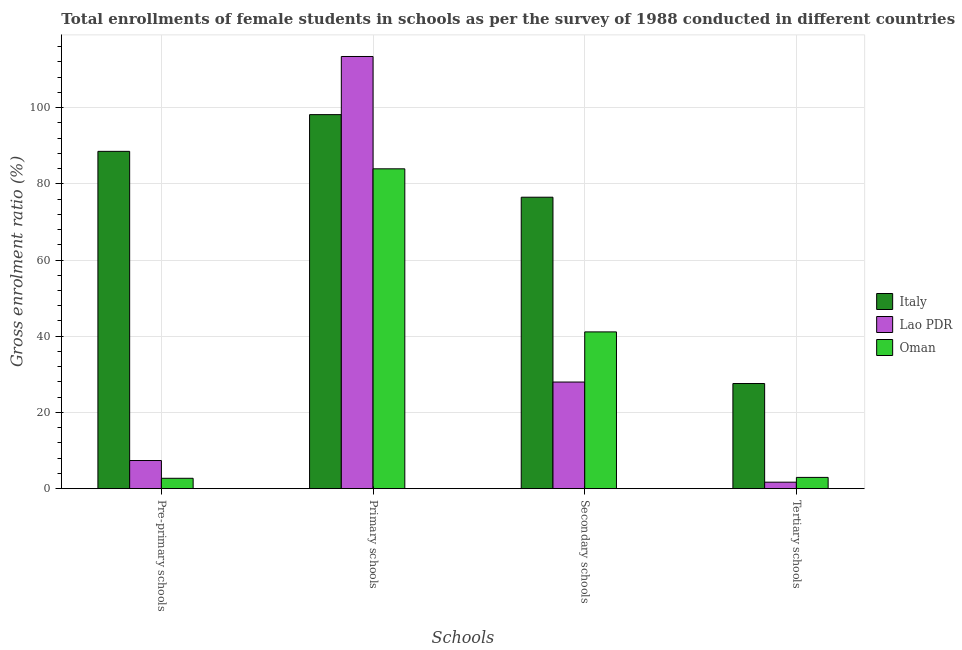How many different coloured bars are there?
Make the answer very short. 3. How many groups of bars are there?
Your response must be concise. 4. Are the number of bars on each tick of the X-axis equal?
Make the answer very short. Yes. How many bars are there on the 3rd tick from the right?
Your answer should be compact. 3. What is the label of the 4th group of bars from the left?
Your response must be concise. Tertiary schools. What is the gross enrolment ratio(female) in secondary schools in Italy?
Provide a short and direct response. 76.48. Across all countries, what is the maximum gross enrolment ratio(female) in primary schools?
Ensure brevity in your answer.  113.4. Across all countries, what is the minimum gross enrolment ratio(female) in pre-primary schools?
Provide a succinct answer. 2.73. In which country was the gross enrolment ratio(female) in pre-primary schools minimum?
Offer a very short reply. Oman. What is the total gross enrolment ratio(female) in primary schools in the graph?
Ensure brevity in your answer.  295.46. What is the difference between the gross enrolment ratio(female) in tertiary schools in Oman and that in Lao PDR?
Keep it short and to the point. 1.25. What is the difference between the gross enrolment ratio(female) in secondary schools in Lao PDR and the gross enrolment ratio(female) in tertiary schools in Italy?
Offer a terse response. 0.39. What is the average gross enrolment ratio(female) in secondary schools per country?
Ensure brevity in your answer.  48.53. What is the difference between the gross enrolment ratio(female) in tertiary schools and gross enrolment ratio(female) in primary schools in Lao PDR?
Your answer should be very brief. -111.69. What is the ratio of the gross enrolment ratio(female) in secondary schools in Lao PDR to that in Italy?
Keep it short and to the point. 0.37. Is the difference between the gross enrolment ratio(female) in pre-primary schools in Oman and Italy greater than the difference between the gross enrolment ratio(female) in primary schools in Oman and Italy?
Your response must be concise. No. What is the difference between the highest and the second highest gross enrolment ratio(female) in tertiary schools?
Offer a very short reply. 24.63. What is the difference between the highest and the lowest gross enrolment ratio(female) in tertiary schools?
Offer a very short reply. 25.88. Is it the case that in every country, the sum of the gross enrolment ratio(female) in primary schools and gross enrolment ratio(female) in pre-primary schools is greater than the sum of gross enrolment ratio(female) in tertiary schools and gross enrolment ratio(female) in secondary schools?
Keep it short and to the point. No. What does the 2nd bar from the left in Tertiary schools represents?
Offer a very short reply. Lao PDR. What does the 2nd bar from the right in Secondary schools represents?
Your answer should be compact. Lao PDR. Are the values on the major ticks of Y-axis written in scientific E-notation?
Provide a succinct answer. No. Does the graph contain grids?
Make the answer very short. Yes. What is the title of the graph?
Keep it short and to the point. Total enrollments of female students in schools as per the survey of 1988 conducted in different countries. What is the label or title of the X-axis?
Keep it short and to the point. Schools. What is the Gross enrolment ratio (%) of Italy in Pre-primary schools?
Ensure brevity in your answer.  88.51. What is the Gross enrolment ratio (%) in Lao PDR in Pre-primary schools?
Ensure brevity in your answer.  7.39. What is the Gross enrolment ratio (%) of Oman in Pre-primary schools?
Your answer should be very brief. 2.73. What is the Gross enrolment ratio (%) of Italy in Primary schools?
Your answer should be very brief. 98.14. What is the Gross enrolment ratio (%) in Lao PDR in Primary schools?
Keep it short and to the point. 113.4. What is the Gross enrolment ratio (%) in Oman in Primary schools?
Keep it short and to the point. 83.92. What is the Gross enrolment ratio (%) of Italy in Secondary schools?
Offer a very short reply. 76.48. What is the Gross enrolment ratio (%) in Lao PDR in Secondary schools?
Your answer should be compact. 27.98. What is the Gross enrolment ratio (%) of Oman in Secondary schools?
Offer a terse response. 41.14. What is the Gross enrolment ratio (%) of Italy in Tertiary schools?
Ensure brevity in your answer.  27.59. What is the Gross enrolment ratio (%) in Lao PDR in Tertiary schools?
Offer a terse response. 1.71. What is the Gross enrolment ratio (%) of Oman in Tertiary schools?
Make the answer very short. 2.96. Across all Schools, what is the maximum Gross enrolment ratio (%) in Italy?
Provide a short and direct response. 98.14. Across all Schools, what is the maximum Gross enrolment ratio (%) of Lao PDR?
Offer a terse response. 113.4. Across all Schools, what is the maximum Gross enrolment ratio (%) in Oman?
Make the answer very short. 83.92. Across all Schools, what is the minimum Gross enrolment ratio (%) of Italy?
Offer a terse response. 27.59. Across all Schools, what is the minimum Gross enrolment ratio (%) in Lao PDR?
Your answer should be very brief. 1.71. Across all Schools, what is the minimum Gross enrolment ratio (%) of Oman?
Keep it short and to the point. 2.73. What is the total Gross enrolment ratio (%) of Italy in the graph?
Keep it short and to the point. 290.71. What is the total Gross enrolment ratio (%) of Lao PDR in the graph?
Provide a succinct answer. 150.47. What is the total Gross enrolment ratio (%) in Oman in the graph?
Ensure brevity in your answer.  130.74. What is the difference between the Gross enrolment ratio (%) in Italy in Pre-primary schools and that in Primary schools?
Provide a succinct answer. -9.63. What is the difference between the Gross enrolment ratio (%) in Lao PDR in Pre-primary schools and that in Primary schools?
Your answer should be very brief. -106.01. What is the difference between the Gross enrolment ratio (%) in Oman in Pre-primary schools and that in Primary schools?
Your answer should be very brief. -81.2. What is the difference between the Gross enrolment ratio (%) of Italy in Pre-primary schools and that in Secondary schools?
Give a very brief answer. 12.03. What is the difference between the Gross enrolment ratio (%) of Lao PDR in Pre-primary schools and that in Secondary schools?
Provide a short and direct response. -20.59. What is the difference between the Gross enrolment ratio (%) of Oman in Pre-primary schools and that in Secondary schools?
Your response must be concise. -38.41. What is the difference between the Gross enrolment ratio (%) of Italy in Pre-primary schools and that in Tertiary schools?
Make the answer very short. 60.92. What is the difference between the Gross enrolment ratio (%) in Lao PDR in Pre-primary schools and that in Tertiary schools?
Your response must be concise. 5.68. What is the difference between the Gross enrolment ratio (%) of Oman in Pre-primary schools and that in Tertiary schools?
Give a very brief answer. -0.23. What is the difference between the Gross enrolment ratio (%) in Italy in Primary schools and that in Secondary schools?
Provide a succinct answer. 21.66. What is the difference between the Gross enrolment ratio (%) of Lao PDR in Primary schools and that in Secondary schools?
Your answer should be compact. 85.42. What is the difference between the Gross enrolment ratio (%) of Oman in Primary schools and that in Secondary schools?
Your answer should be very brief. 42.79. What is the difference between the Gross enrolment ratio (%) of Italy in Primary schools and that in Tertiary schools?
Your response must be concise. 70.55. What is the difference between the Gross enrolment ratio (%) of Lao PDR in Primary schools and that in Tertiary schools?
Provide a succinct answer. 111.69. What is the difference between the Gross enrolment ratio (%) in Oman in Primary schools and that in Tertiary schools?
Provide a short and direct response. 80.97. What is the difference between the Gross enrolment ratio (%) in Italy in Secondary schools and that in Tertiary schools?
Make the answer very short. 48.89. What is the difference between the Gross enrolment ratio (%) in Lao PDR in Secondary schools and that in Tertiary schools?
Your answer should be compact. 26.27. What is the difference between the Gross enrolment ratio (%) of Oman in Secondary schools and that in Tertiary schools?
Your answer should be compact. 38.18. What is the difference between the Gross enrolment ratio (%) of Italy in Pre-primary schools and the Gross enrolment ratio (%) of Lao PDR in Primary schools?
Your response must be concise. -24.89. What is the difference between the Gross enrolment ratio (%) of Italy in Pre-primary schools and the Gross enrolment ratio (%) of Oman in Primary schools?
Ensure brevity in your answer.  4.58. What is the difference between the Gross enrolment ratio (%) in Lao PDR in Pre-primary schools and the Gross enrolment ratio (%) in Oman in Primary schools?
Your answer should be compact. -76.54. What is the difference between the Gross enrolment ratio (%) in Italy in Pre-primary schools and the Gross enrolment ratio (%) in Lao PDR in Secondary schools?
Ensure brevity in your answer.  60.53. What is the difference between the Gross enrolment ratio (%) in Italy in Pre-primary schools and the Gross enrolment ratio (%) in Oman in Secondary schools?
Ensure brevity in your answer.  47.37. What is the difference between the Gross enrolment ratio (%) in Lao PDR in Pre-primary schools and the Gross enrolment ratio (%) in Oman in Secondary schools?
Offer a terse response. -33.75. What is the difference between the Gross enrolment ratio (%) of Italy in Pre-primary schools and the Gross enrolment ratio (%) of Lao PDR in Tertiary schools?
Make the answer very short. 86.8. What is the difference between the Gross enrolment ratio (%) of Italy in Pre-primary schools and the Gross enrolment ratio (%) of Oman in Tertiary schools?
Provide a short and direct response. 85.55. What is the difference between the Gross enrolment ratio (%) in Lao PDR in Pre-primary schools and the Gross enrolment ratio (%) in Oman in Tertiary schools?
Give a very brief answer. 4.43. What is the difference between the Gross enrolment ratio (%) in Italy in Primary schools and the Gross enrolment ratio (%) in Lao PDR in Secondary schools?
Offer a terse response. 70.16. What is the difference between the Gross enrolment ratio (%) of Italy in Primary schools and the Gross enrolment ratio (%) of Oman in Secondary schools?
Provide a short and direct response. 57.01. What is the difference between the Gross enrolment ratio (%) in Lao PDR in Primary schools and the Gross enrolment ratio (%) in Oman in Secondary schools?
Make the answer very short. 72.26. What is the difference between the Gross enrolment ratio (%) of Italy in Primary schools and the Gross enrolment ratio (%) of Lao PDR in Tertiary schools?
Offer a very short reply. 96.44. What is the difference between the Gross enrolment ratio (%) in Italy in Primary schools and the Gross enrolment ratio (%) in Oman in Tertiary schools?
Your answer should be compact. 95.18. What is the difference between the Gross enrolment ratio (%) of Lao PDR in Primary schools and the Gross enrolment ratio (%) of Oman in Tertiary schools?
Keep it short and to the point. 110.44. What is the difference between the Gross enrolment ratio (%) in Italy in Secondary schools and the Gross enrolment ratio (%) in Lao PDR in Tertiary schools?
Offer a terse response. 74.77. What is the difference between the Gross enrolment ratio (%) in Italy in Secondary schools and the Gross enrolment ratio (%) in Oman in Tertiary schools?
Ensure brevity in your answer.  73.52. What is the difference between the Gross enrolment ratio (%) in Lao PDR in Secondary schools and the Gross enrolment ratio (%) in Oman in Tertiary schools?
Provide a short and direct response. 25.02. What is the average Gross enrolment ratio (%) of Italy per Schools?
Offer a terse response. 72.68. What is the average Gross enrolment ratio (%) in Lao PDR per Schools?
Make the answer very short. 37.62. What is the average Gross enrolment ratio (%) of Oman per Schools?
Provide a succinct answer. 32.69. What is the difference between the Gross enrolment ratio (%) of Italy and Gross enrolment ratio (%) of Lao PDR in Pre-primary schools?
Ensure brevity in your answer.  81.12. What is the difference between the Gross enrolment ratio (%) in Italy and Gross enrolment ratio (%) in Oman in Pre-primary schools?
Provide a succinct answer. 85.78. What is the difference between the Gross enrolment ratio (%) in Lao PDR and Gross enrolment ratio (%) in Oman in Pre-primary schools?
Make the answer very short. 4.66. What is the difference between the Gross enrolment ratio (%) in Italy and Gross enrolment ratio (%) in Lao PDR in Primary schools?
Make the answer very short. -15.26. What is the difference between the Gross enrolment ratio (%) of Italy and Gross enrolment ratio (%) of Oman in Primary schools?
Your answer should be very brief. 14.22. What is the difference between the Gross enrolment ratio (%) in Lao PDR and Gross enrolment ratio (%) in Oman in Primary schools?
Your answer should be very brief. 29.48. What is the difference between the Gross enrolment ratio (%) of Italy and Gross enrolment ratio (%) of Lao PDR in Secondary schools?
Your response must be concise. 48.5. What is the difference between the Gross enrolment ratio (%) in Italy and Gross enrolment ratio (%) in Oman in Secondary schools?
Your answer should be very brief. 35.34. What is the difference between the Gross enrolment ratio (%) of Lao PDR and Gross enrolment ratio (%) of Oman in Secondary schools?
Your answer should be very brief. -13.16. What is the difference between the Gross enrolment ratio (%) of Italy and Gross enrolment ratio (%) of Lao PDR in Tertiary schools?
Offer a terse response. 25.88. What is the difference between the Gross enrolment ratio (%) of Italy and Gross enrolment ratio (%) of Oman in Tertiary schools?
Your answer should be compact. 24.63. What is the difference between the Gross enrolment ratio (%) in Lao PDR and Gross enrolment ratio (%) in Oman in Tertiary schools?
Provide a short and direct response. -1.25. What is the ratio of the Gross enrolment ratio (%) in Italy in Pre-primary schools to that in Primary schools?
Ensure brevity in your answer.  0.9. What is the ratio of the Gross enrolment ratio (%) in Lao PDR in Pre-primary schools to that in Primary schools?
Provide a succinct answer. 0.07. What is the ratio of the Gross enrolment ratio (%) in Oman in Pre-primary schools to that in Primary schools?
Your response must be concise. 0.03. What is the ratio of the Gross enrolment ratio (%) in Italy in Pre-primary schools to that in Secondary schools?
Provide a short and direct response. 1.16. What is the ratio of the Gross enrolment ratio (%) of Lao PDR in Pre-primary schools to that in Secondary schools?
Offer a very short reply. 0.26. What is the ratio of the Gross enrolment ratio (%) in Oman in Pre-primary schools to that in Secondary schools?
Provide a succinct answer. 0.07. What is the ratio of the Gross enrolment ratio (%) of Italy in Pre-primary schools to that in Tertiary schools?
Offer a terse response. 3.21. What is the ratio of the Gross enrolment ratio (%) in Lao PDR in Pre-primary schools to that in Tertiary schools?
Your response must be concise. 4.33. What is the ratio of the Gross enrolment ratio (%) of Oman in Pre-primary schools to that in Tertiary schools?
Offer a terse response. 0.92. What is the ratio of the Gross enrolment ratio (%) in Italy in Primary schools to that in Secondary schools?
Your answer should be very brief. 1.28. What is the ratio of the Gross enrolment ratio (%) of Lao PDR in Primary schools to that in Secondary schools?
Your answer should be compact. 4.05. What is the ratio of the Gross enrolment ratio (%) in Oman in Primary schools to that in Secondary schools?
Make the answer very short. 2.04. What is the ratio of the Gross enrolment ratio (%) in Italy in Primary schools to that in Tertiary schools?
Keep it short and to the point. 3.56. What is the ratio of the Gross enrolment ratio (%) of Lao PDR in Primary schools to that in Tertiary schools?
Make the answer very short. 66.49. What is the ratio of the Gross enrolment ratio (%) of Oman in Primary schools to that in Tertiary schools?
Provide a succinct answer. 28.37. What is the ratio of the Gross enrolment ratio (%) of Italy in Secondary schools to that in Tertiary schools?
Make the answer very short. 2.77. What is the ratio of the Gross enrolment ratio (%) of Lao PDR in Secondary schools to that in Tertiary schools?
Your response must be concise. 16.41. What is the ratio of the Gross enrolment ratio (%) of Oman in Secondary schools to that in Tertiary schools?
Offer a terse response. 13.9. What is the difference between the highest and the second highest Gross enrolment ratio (%) of Italy?
Provide a short and direct response. 9.63. What is the difference between the highest and the second highest Gross enrolment ratio (%) of Lao PDR?
Your answer should be compact. 85.42. What is the difference between the highest and the second highest Gross enrolment ratio (%) of Oman?
Your answer should be compact. 42.79. What is the difference between the highest and the lowest Gross enrolment ratio (%) in Italy?
Offer a terse response. 70.55. What is the difference between the highest and the lowest Gross enrolment ratio (%) in Lao PDR?
Your answer should be compact. 111.69. What is the difference between the highest and the lowest Gross enrolment ratio (%) in Oman?
Your answer should be very brief. 81.2. 